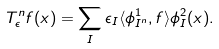Convert formula to latex. <formula><loc_0><loc_0><loc_500><loc_500>T _ { \epsilon } ^ { n } f ( x ) = \sum _ { I } \epsilon _ { I } \langle \phi _ { I ^ { n } } ^ { 1 } , f \rangle \phi _ { I } ^ { 2 } ( x ) .</formula> 